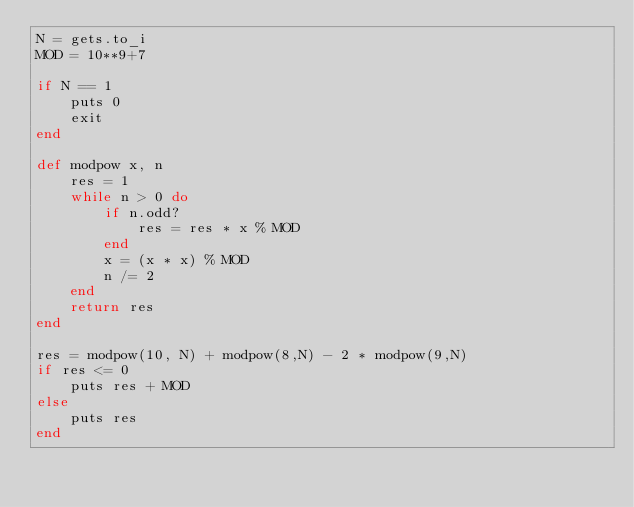Convert code to text. <code><loc_0><loc_0><loc_500><loc_500><_Ruby_>N = gets.to_i
MOD = 10**9+7

if N == 1
    puts 0
    exit
end

def modpow x, n
    res = 1
    while n > 0 do
        if n.odd?
            res = res * x % MOD
        end
        x = (x * x) % MOD
        n /= 2
    end
    return res
end

res = modpow(10, N) + modpow(8,N) - 2 * modpow(9,N)
if res <= 0
    puts res + MOD
else
    puts res
end</code> 